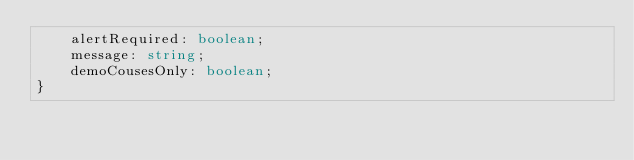Convert code to text. <code><loc_0><loc_0><loc_500><loc_500><_TypeScript_>    alertRequired: boolean;
    message: string;
    demoCousesOnly: boolean;
}
</code> 